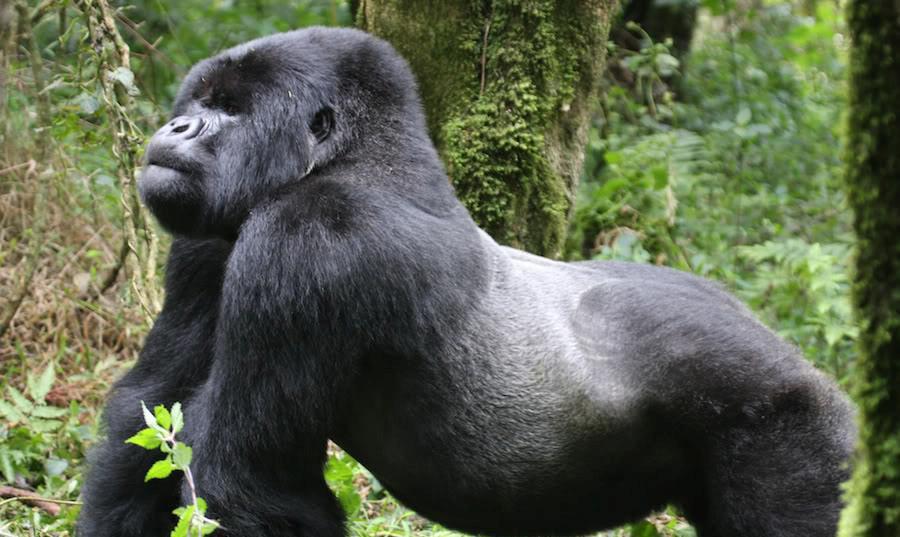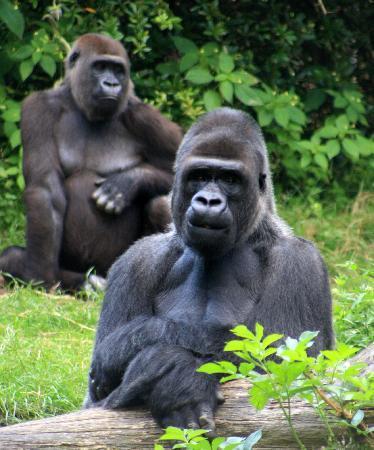The first image is the image on the left, the second image is the image on the right. Assess this claim about the two images: "The combined images include a gorilla with crossed arms and a gorilla on all fours, and at least one gorilla depicted is a real animal.". Correct or not? Answer yes or no. Yes. The first image is the image on the left, the second image is the image on the right. Considering the images on both sides, is "There are more than 2 gorillas depicted." valid? Answer yes or no. Yes. 